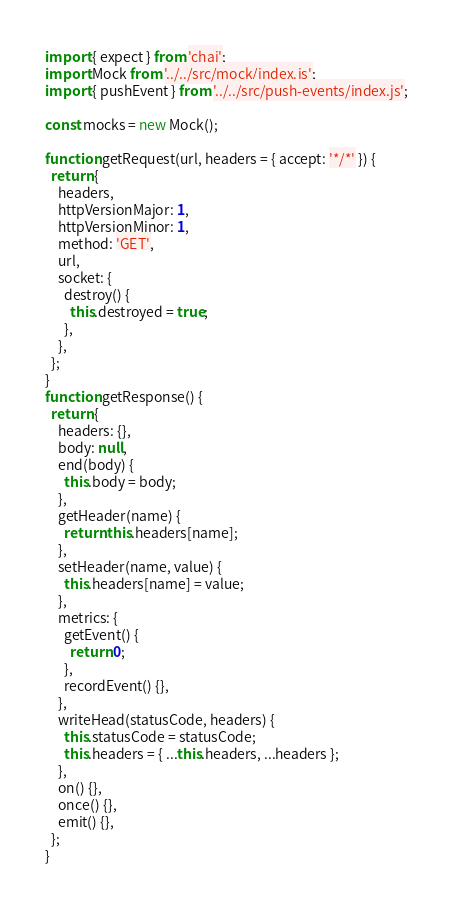<code> <loc_0><loc_0><loc_500><loc_500><_JavaScript_>import { expect } from 'chai';
import Mock from '../../src/mock/index.js';
import { pushEvent } from '../../src/push-events/index.js';

const mocks = new Mock();

function getRequest(url, headers = { accept: '*/*' }) {
  return {
    headers,
    httpVersionMajor: 1,
    httpVersionMinor: 1,
    method: 'GET',
    url,
    socket: {
      destroy() {
        this.destroyed = true;
      },
    },
  };
}
function getResponse() {
  return {
    headers: {},
    body: null,
    end(body) {
      this.body = body;
    },
    getHeader(name) {
      return this.headers[name];
    },
    setHeader(name, value) {
      this.headers[name] = value;
    },
    metrics: {
      getEvent() {
        return 0;
      },
      recordEvent() {},
    },
    writeHead(statusCode, headers) {
      this.statusCode = statusCode;
      this.headers = { ...this.headers, ...headers };
    },
    on() {},
    once() {},
    emit() {},
  };
}
</code> 